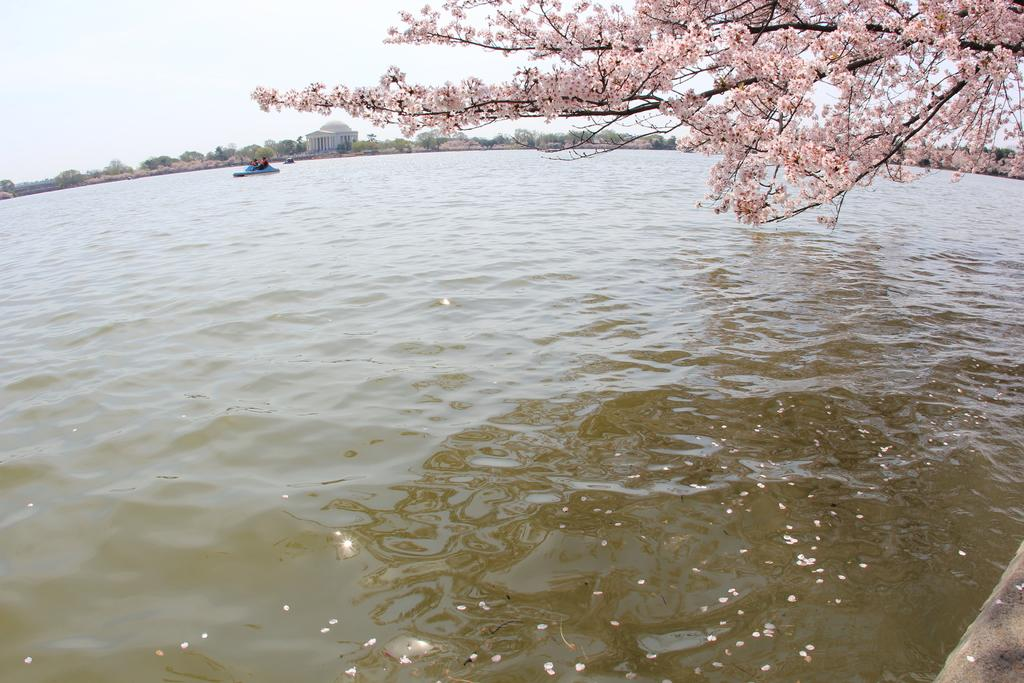What type of vehicles are in the water in the image? There are boats in the water in the image. What is the primary element in which the boats are situated? The boats are situated in water. What can be seen in the background of the image? There are trees, a building, and the sky visible in the background of the image. How many cats are sitting on the man's lap in the image? There are no cats or man present in the image. 